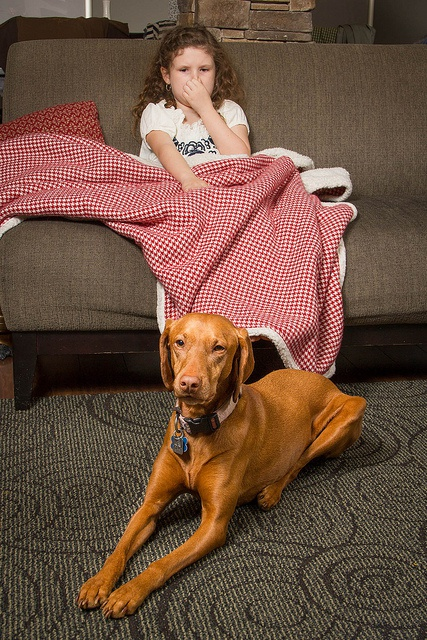Describe the objects in this image and their specific colors. I can see couch in gray, maroon, and black tones, dog in gray, brown, maroon, and black tones, and people in gray, tan, lightgray, maroon, and black tones in this image. 